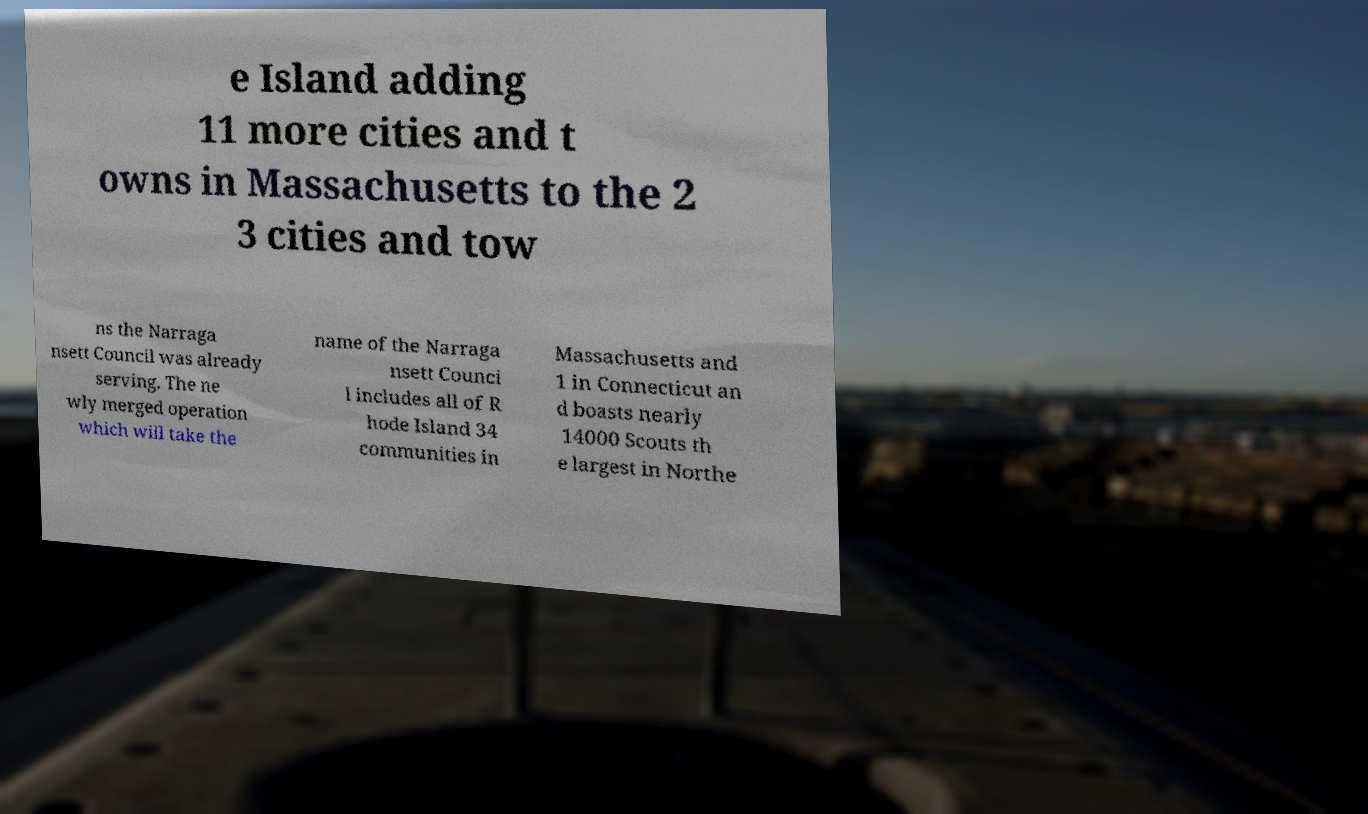Please identify and transcribe the text found in this image. e Island adding 11 more cities and t owns in Massachusetts to the 2 3 cities and tow ns the Narraga nsett Council was already serving. The ne wly merged operation which will take the name of the Narraga nsett Counci l includes all of R hode Island 34 communities in Massachusetts and 1 in Connecticut an d boasts nearly 14000 Scouts th e largest in Northe 